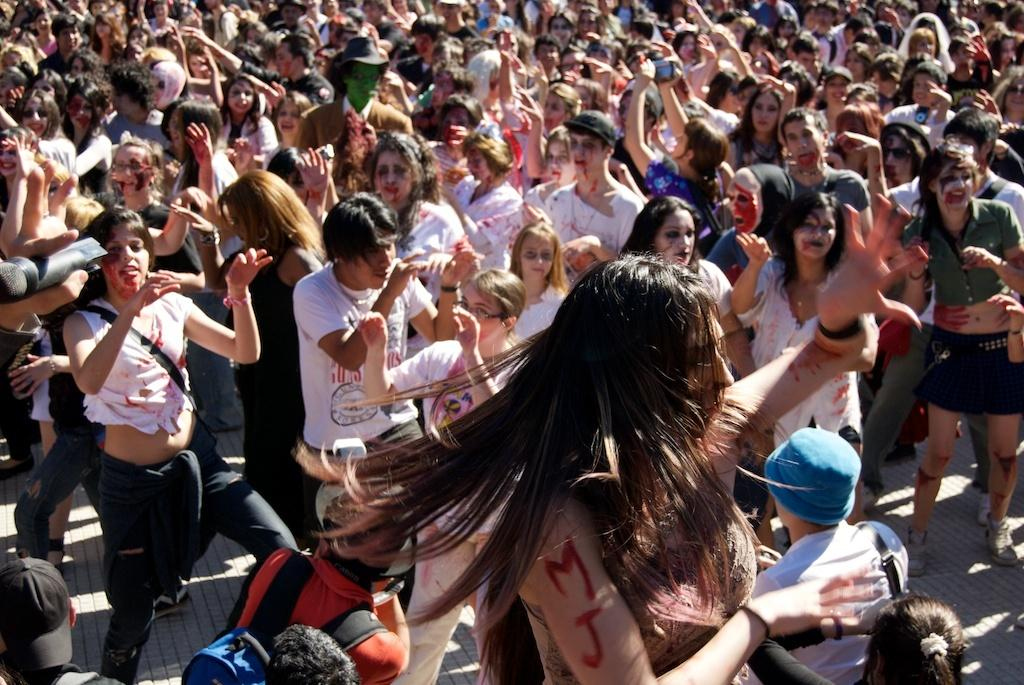How many people are in the group that is visible in the image? There is a group of people in the image. What can be observed on the faces of the people in the image? The people have face paint. What action are the people in the image performing? The people are dancing by raising their hands. What event or occasion might the scene in the image be related to? The scene appears to be related to Halloween. Can you tell me how many caves are visible in the image? There are no caves present in the image; it features a group of people with face paint who are dancing. 